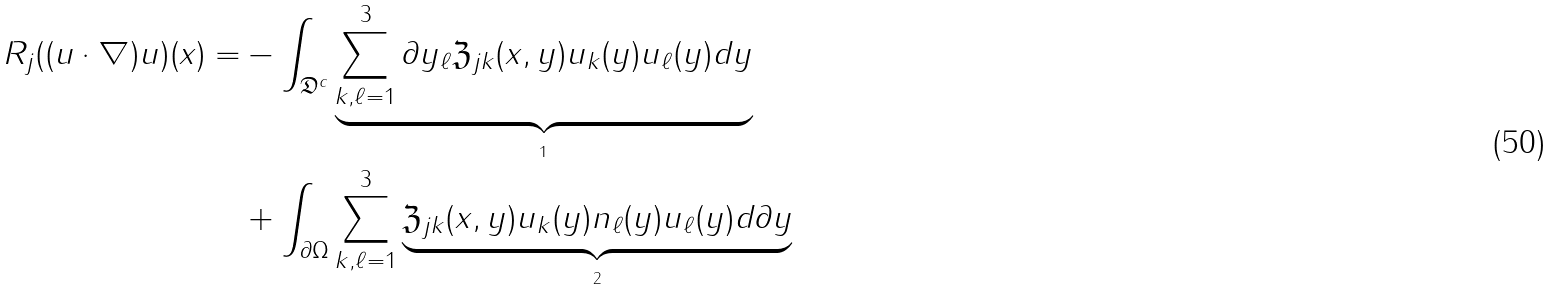<formula> <loc_0><loc_0><loc_500><loc_500>R _ { j } ( ( u \cdot \nabla ) u ) ( x ) = & - \int _ { \mathfrak D ^ { c } } \underbrace { \sum ^ { 3 } _ { k , \ell = 1 } \partial y _ { \ell } \mathfrak Z _ { j k } ( x , y ) u _ { k } ( y ) u _ { \ell } ( y ) d y } _ { _ { 1 } } \\ & + \int _ { \partial \Omega } \sum ^ { 3 } _ { k , \ell = 1 } \underbrace { \mathfrak Z _ { j k } ( x , y ) u _ { k } ( y ) n _ { \ell } ( y ) u _ { \ell } ( y ) d \partial y } _ { _ { 2 } }</formula> 